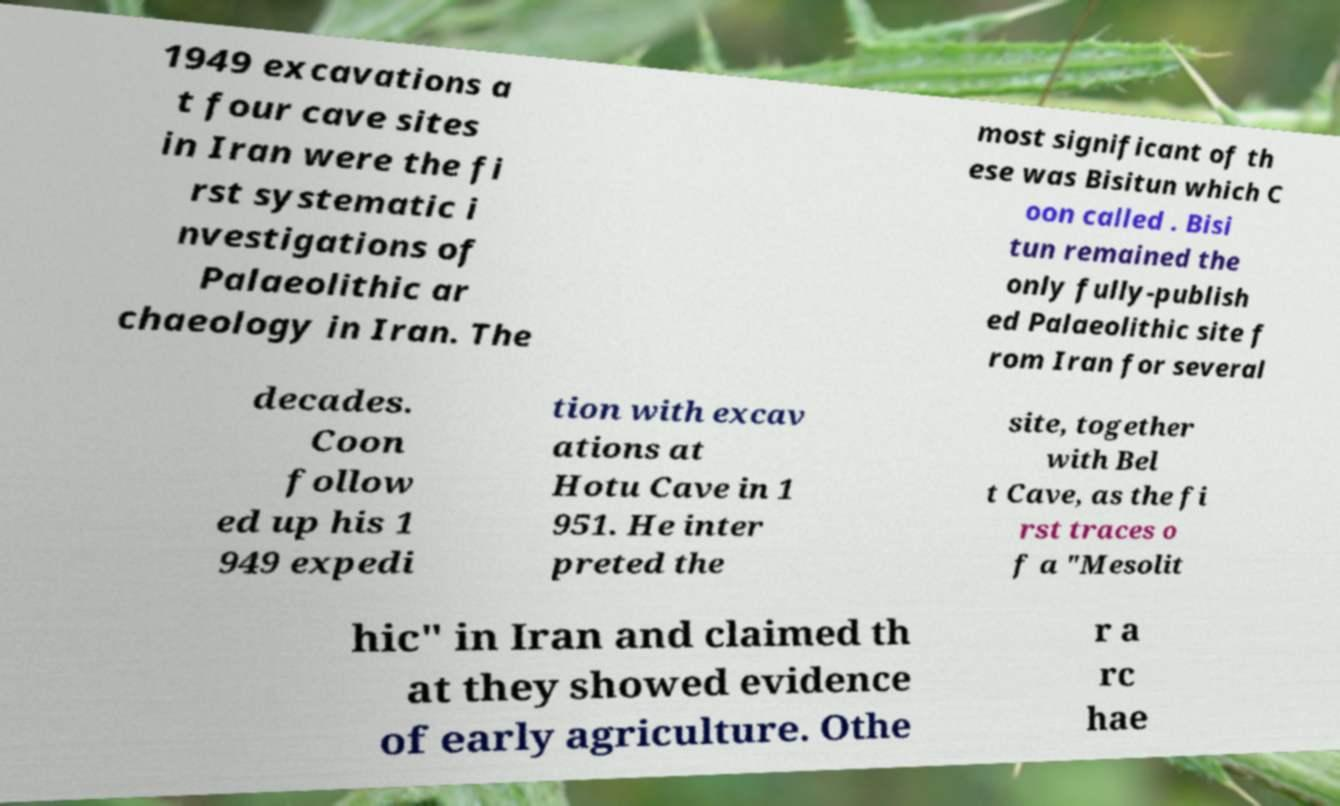What messages or text are displayed in this image? I need them in a readable, typed format. 1949 excavations a t four cave sites in Iran were the fi rst systematic i nvestigations of Palaeolithic ar chaeology in Iran. The most significant of th ese was Bisitun which C oon called . Bisi tun remained the only fully-publish ed Palaeolithic site f rom Iran for several decades. Coon follow ed up his 1 949 expedi tion with excav ations at Hotu Cave in 1 951. He inter preted the site, together with Bel t Cave, as the fi rst traces o f a "Mesolit hic" in Iran and claimed th at they showed evidence of early agriculture. Othe r a rc hae 